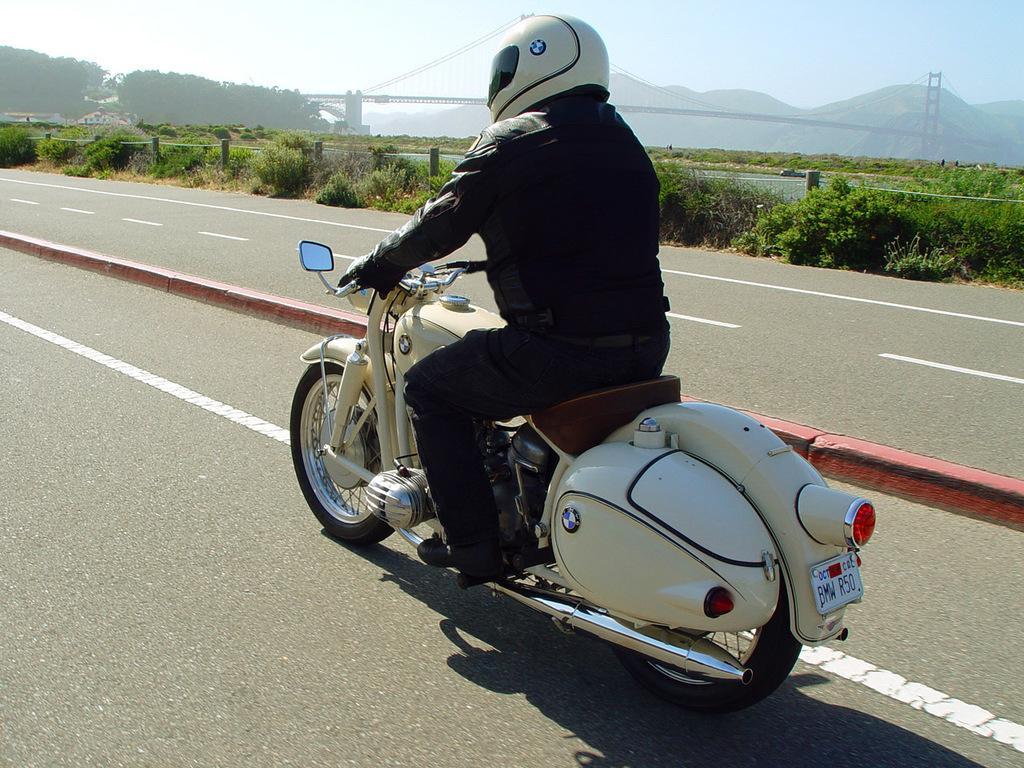In one or two sentences, can you explain what this image depicts? In this picture outside of the city. He is riding a motorcycle. He is wearing a black jacket. He is wearing a helmet. We can see in background sky,tree,mountain and bridge. 